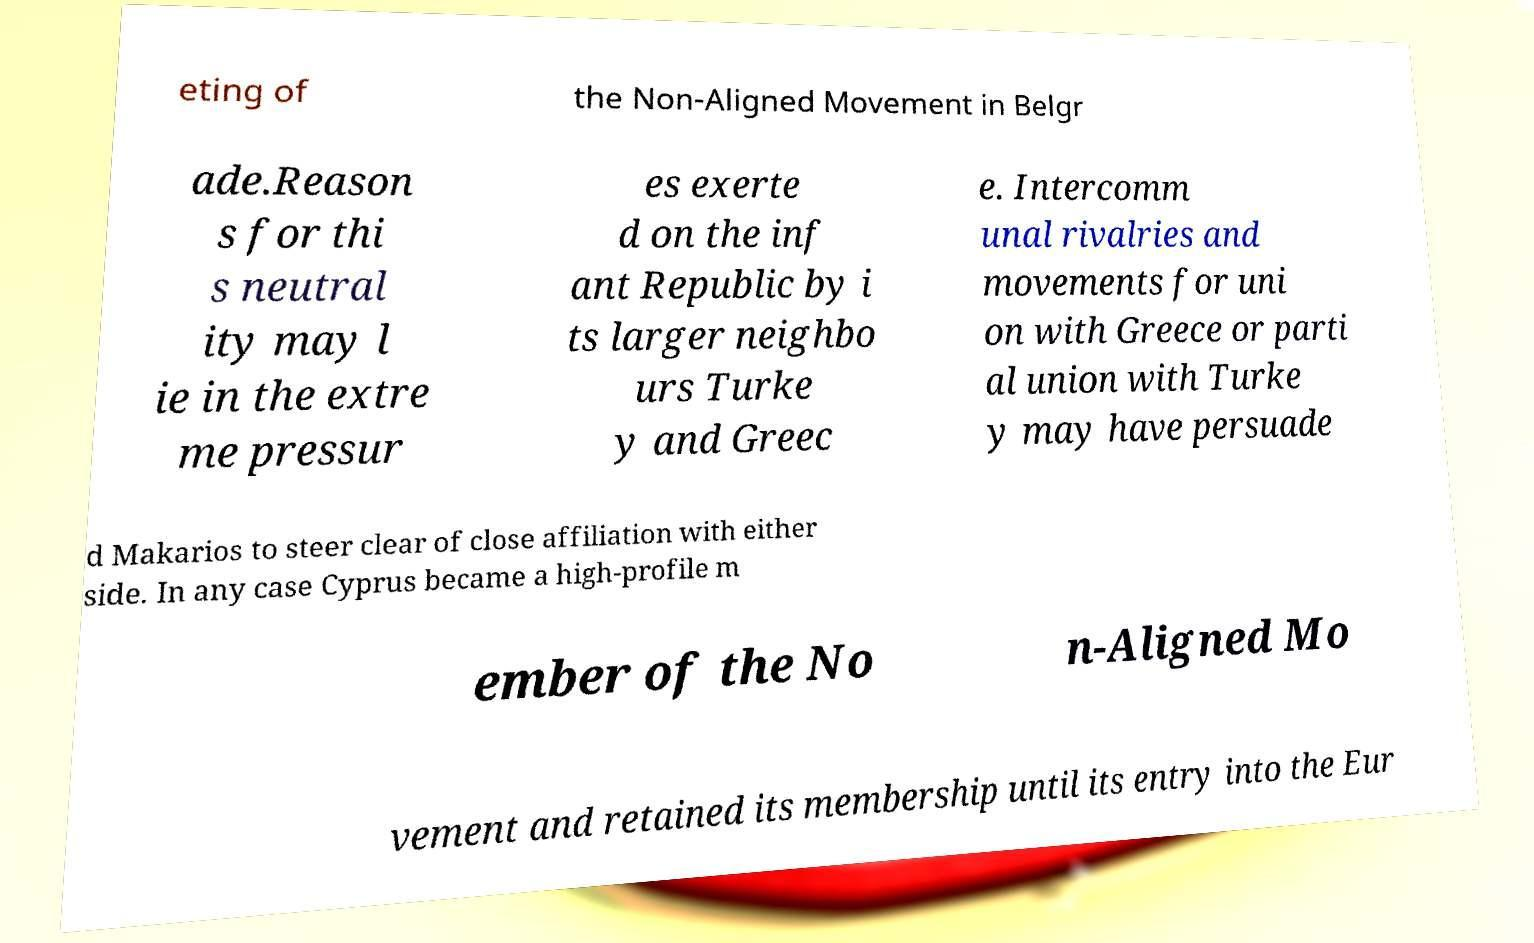Can you read and provide the text displayed in the image?This photo seems to have some interesting text. Can you extract and type it out for me? eting of the Non-Aligned Movement in Belgr ade.Reason s for thi s neutral ity may l ie in the extre me pressur es exerte d on the inf ant Republic by i ts larger neighbo urs Turke y and Greec e. Intercomm unal rivalries and movements for uni on with Greece or parti al union with Turke y may have persuade d Makarios to steer clear of close affiliation with either side. In any case Cyprus became a high-profile m ember of the No n-Aligned Mo vement and retained its membership until its entry into the Eur 